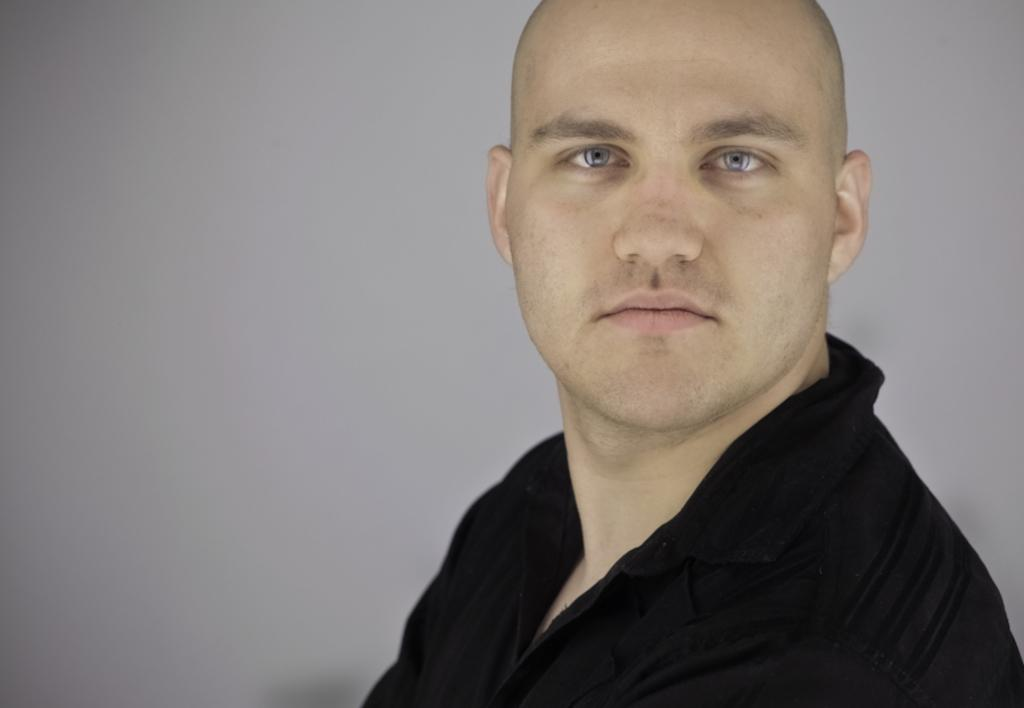What is present in the image? There is a man in the image. What is the man wearing? The man is wearing a black shirt. What is the color of the background in the image? The background of the image is gray in color. What type of plough is the man using in the image? There is no plough present in the image; it features a man wearing a black shirt with a gray background. How many cats can be seen in the image? There are no cats present in the image. 